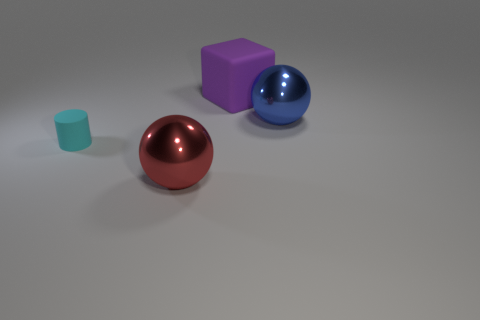Add 3 tiny red cylinders. How many objects exist? 7 Subtract all cylinders. How many objects are left? 3 Add 3 large red things. How many large red things exist? 4 Subtract 1 blue spheres. How many objects are left? 3 Subtract all big blue metal balls. Subtract all rubber cubes. How many objects are left? 2 Add 1 blue metallic things. How many blue metallic things are left? 2 